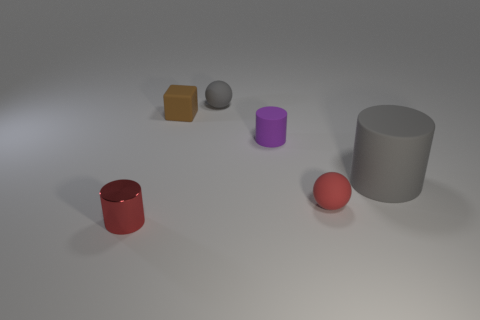What is the material of the sphere that is the same color as the big rubber object?
Provide a short and direct response. Rubber. The thing that is the same color as the large rubber cylinder is what size?
Provide a short and direct response. Small. What is the shape of the tiny object that is on the right side of the small purple matte cylinder?
Ensure brevity in your answer.  Sphere. There is a tiny metal thing; does it have the same shape as the object behind the tiny rubber block?
Offer a terse response. No. There is a object that is both in front of the large cylinder and on the right side of the tiny gray thing; what size is it?
Give a very brief answer. Small. The cylinder that is both in front of the tiny rubber cylinder and on the right side of the gray sphere is what color?
Offer a terse response. Gray. Is there anything else that is made of the same material as the gray ball?
Your answer should be compact. Yes. Is the number of purple things that are left of the brown matte block less than the number of gray things that are left of the small red sphere?
Make the answer very short. Yes. Are there any other things that are the same color as the tiny rubber cube?
Offer a terse response. No. The red metallic thing has what shape?
Provide a succinct answer. Cylinder. 